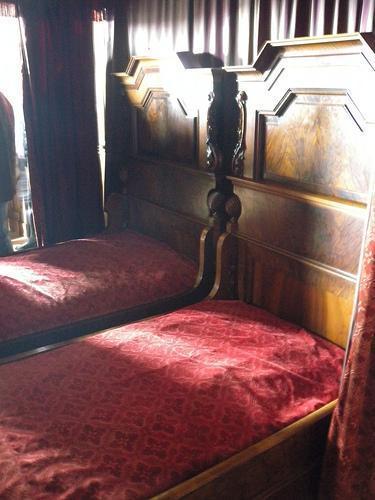How many beds are in the picture?
Give a very brief answer. 2. 